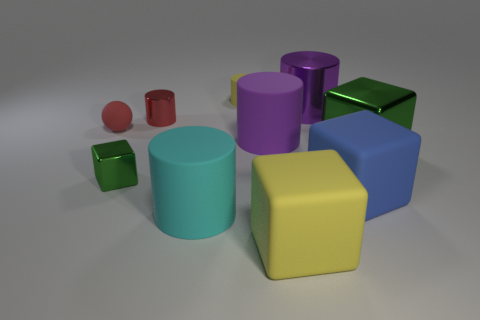Subtract all big cyan cylinders. How many cylinders are left? 4 Subtract all red cylinders. How many cylinders are left? 4 Subtract 1 cylinders. How many cylinders are left? 4 Subtract all brown cylinders. Subtract all yellow blocks. How many cylinders are left? 5 Subtract all spheres. How many objects are left? 9 Subtract 1 yellow cylinders. How many objects are left? 9 Subtract all small red matte blocks. Subtract all small green objects. How many objects are left? 9 Add 5 rubber cubes. How many rubber cubes are left? 7 Add 6 tiny red cubes. How many tiny red cubes exist? 6 